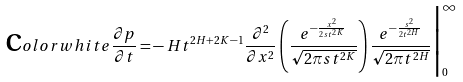Convert formula to latex. <formula><loc_0><loc_0><loc_500><loc_500>\text  color{white} { \frac { \partial p } { \partial t } = } - H t ^ { 2 H + 2 K - 1 } \frac { \partial ^ { 2 } } { \partial x ^ { 2 } } \left ( \frac { e ^ { - \frac { x ^ { 2 } } { 2 s t ^ { 2 K } } } } { \sqrt { 2 \pi s t ^ { 2 K } } } \right ) \frac { e ^ { - \frac { s ^ { 2 } } { 2 t ^ { 2 H } } } } { \sqrt { 2 \pi t ^ { 2 H } } } \Big | _ { 0 } ^ { \infty }</formula> 